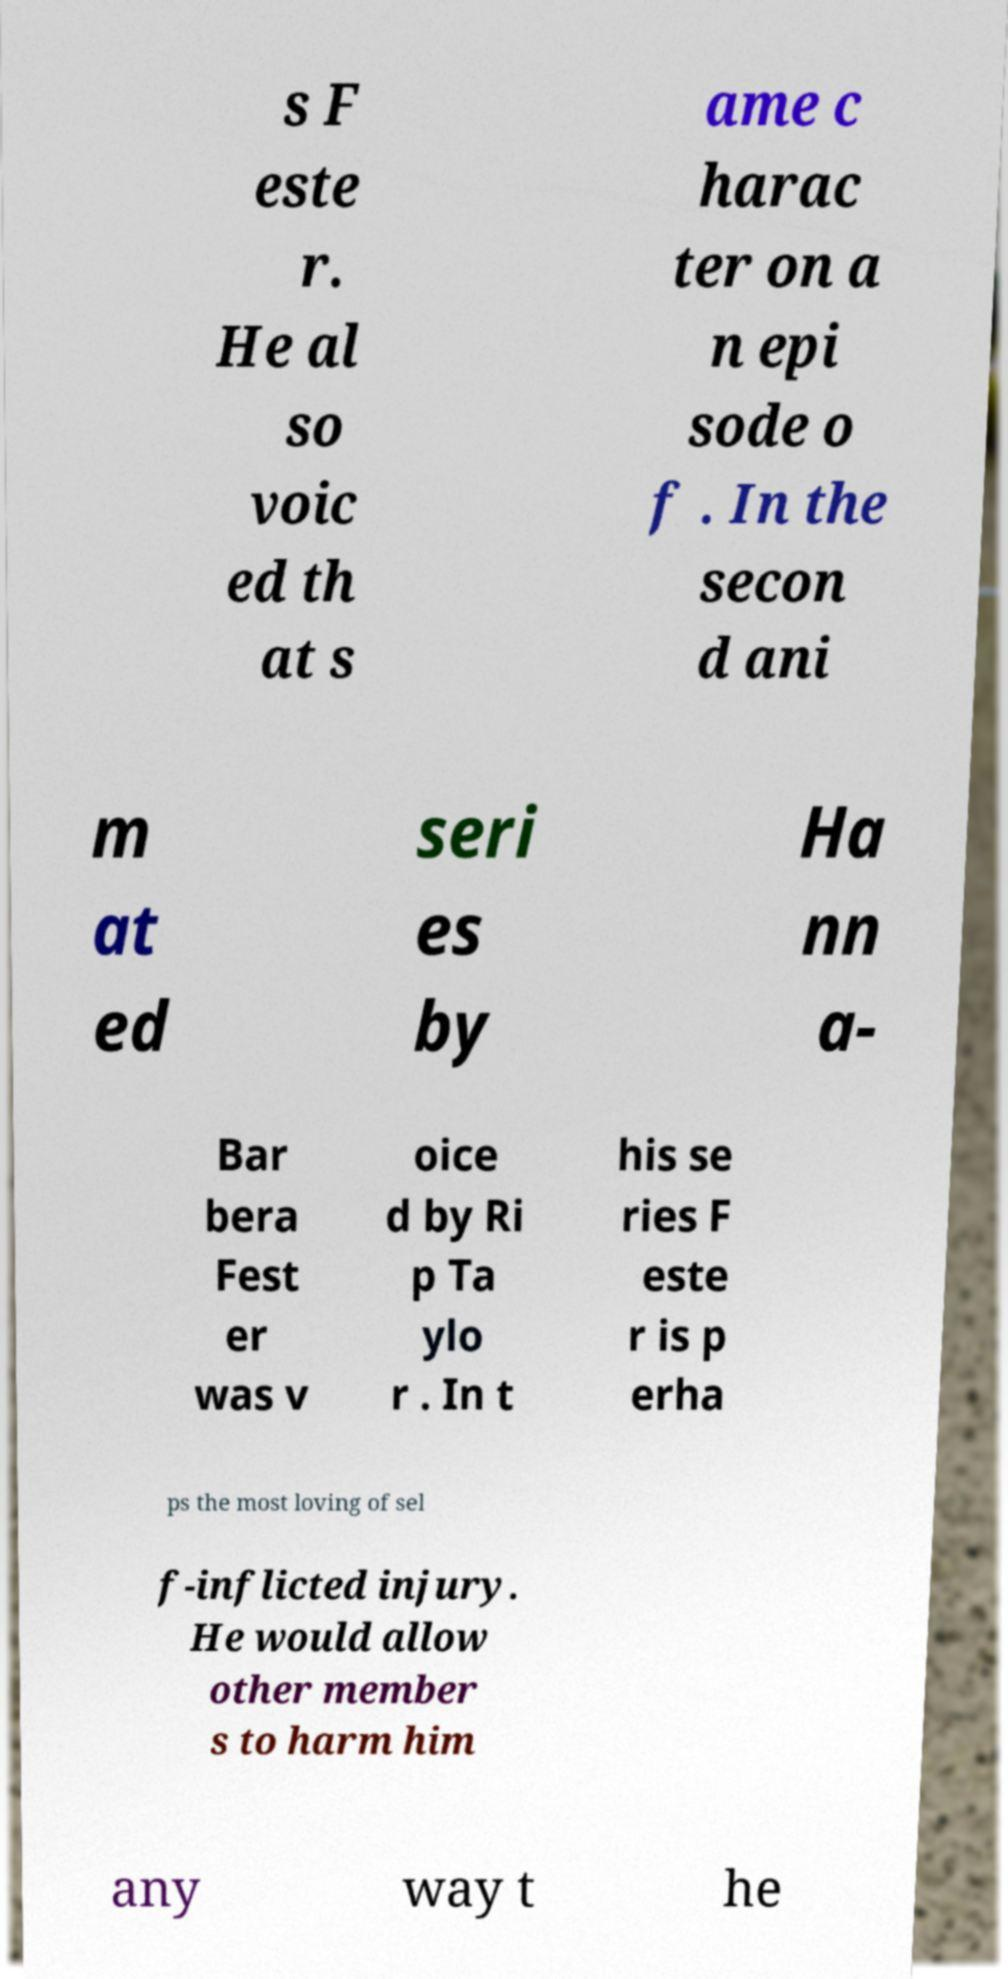What messages or text are displayed in this image? I need them in a readable, typed format. s F este r. He al so voic ed th at s ame c harac ter on a n epi sode o f . In the secon d ani m at ed seri es by Ha nn a- Bar bera Fest er was v oice d by Ri p Ta ylo r . In t his se ries F este r is p erha ps the most loving of sel f-inflicted injury. He would allow other member s to harm him any way t he 